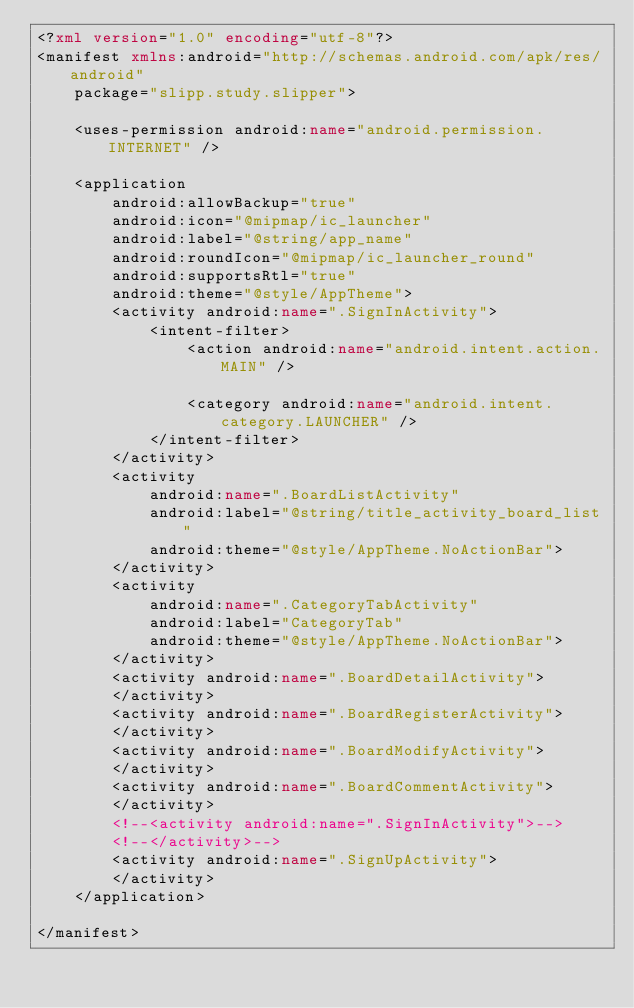<code> <loc_0><loc_0><loc_500><loc_500><_XML_><?xml version="1.0" encoding="utf-8"?>
<manifest xmlns:android="http://schemas.android.com/apk/res/android"
    package="slipp.study.slipper">

    <uses-permission android:name="android.permission.INTERNET" />

    <application
        android:allowBackup="true"
        android:icon="@mipmap/ic_launcher"
        android:label="@string/app_name"
        android:roundIcon="@mipmap/ic_launcher_round"
        android:supportsRtl="true"
        android:theme="@style/AppTheme">
        <activity android:name=".SignInActivity">
            <intent-filter>
                <action android:name="android.intent.action.MAIN" />

                <category android:name="android.intent.category.LAUNCHER" />
            </intent-filter>
        </activity>
        <activity
            android:name=".BoardListActivity"
            android:label="@string/title_activity_board_list"
            android:theme="@style/AppTheme.NoActionBar">
        </activity>
        <activity
            android:name=".CategoryTabActivity"
            android:label="CategoryTab"
            android:theme="@style/AppTheme.NoActionBar">
        </activity>
        <activity android:name=".BoardDetailActivity">
        </activity>
        <activity android:name=".BoardRegisterActivity">
        </activity>
        <activity android:name=".BoardModifyActivity">
        </activity>
        <activity android:name=".BoardCommentActivity">
        </activity>
        <!--<activity android:name=".SignInActivity">-->
        <!--</activity>-->
        <activity android:name=".SignUpActivity">
        </activity>
    </application>

</manifest></code> 